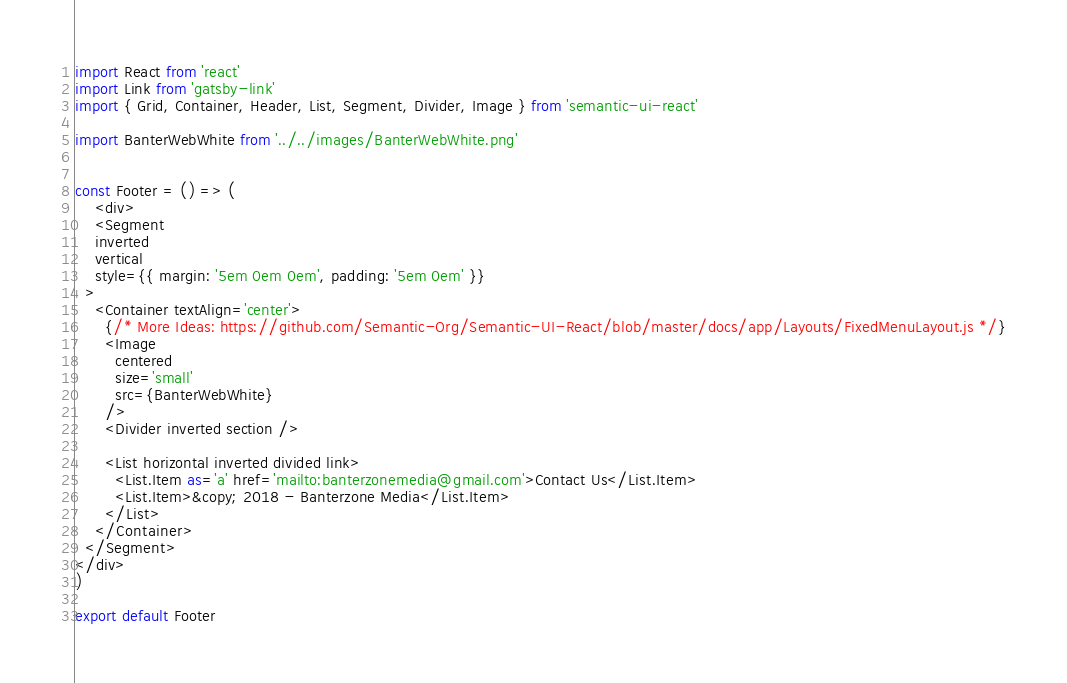Convert code to text. <code><loc_0><loc_0><loc_500><loc_500><_JavaScript_>import React from 'react'
import Link from 'gatsby-link'
import { Grid, Container, Header, List, Segment, Divider, Image } from 'semantic-ui-react'

import BanterWebWhite from '../../images/BanterWebWhite.png'


const Footer = () => (
    <div>
    <Segment
    inverted
    vertical
    style={{ margin: '5em 0em 0em', padding: '5em 0em' }}
  >
    <Container textAlign='center'>
      {/* More Ideas: https://github.com/Semantic-Org/Semantic-UI-React/blob/master/docs/app/Layouts/FixedMenuLayout.js */}
      <Image
        centered
        size='small'
        src={BanterWebWhite}
      />
      <Divider inverted section />
      
      <List horizontal inverted divided link>
        <List.Item as='a' href='mailto:banterzonemedia@gmail.com'>Contact Us</List.Item>
        <List.Item>&copy; 2018 - Banterzone Media</List.Item>
      </List>
    </Container>
  </Segment>
</div>
)

export default Footer</code> 